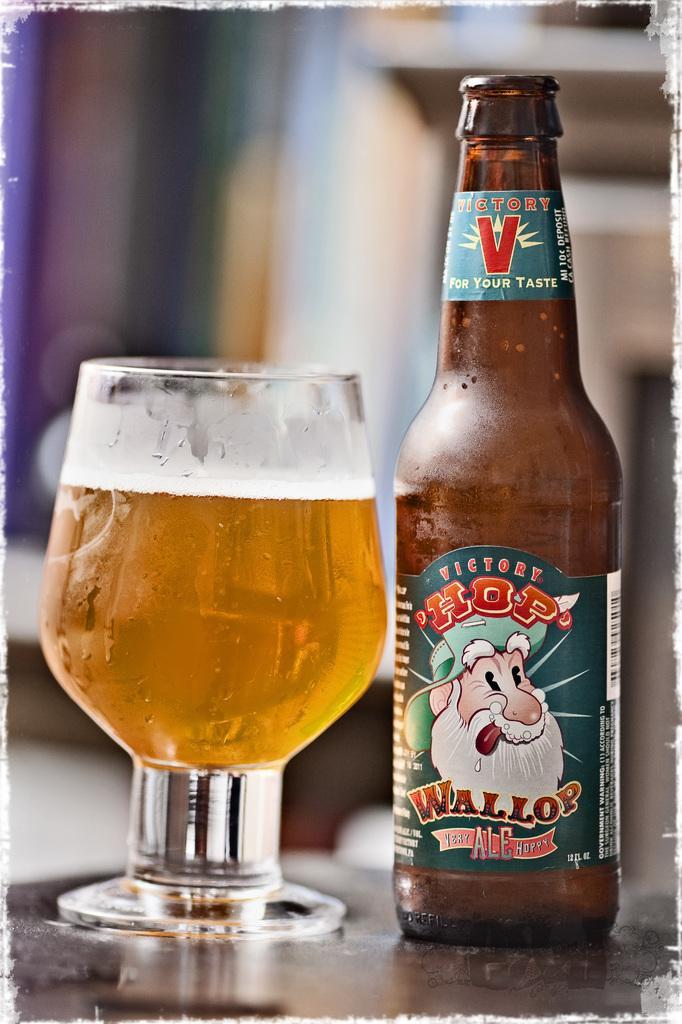In one or two sentences, can you explain what this image depicts? In this image i can see a bottle and glass with beer in it,I can see a sticker attached to the beer bottle on which there is a person with white beard. 